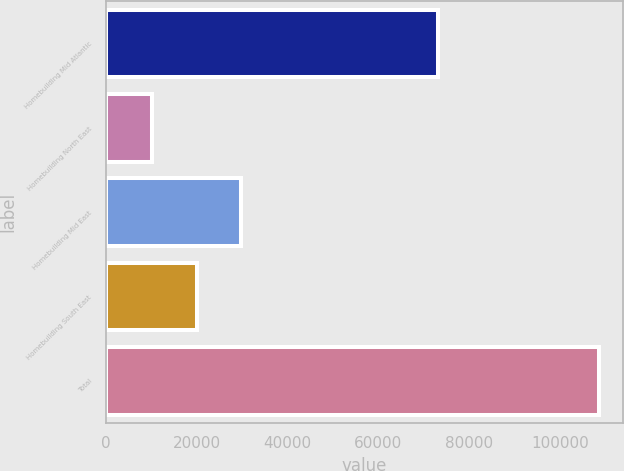Convert chart. <chart><loc_0><loc_0><loc_500><loc_500><bar_chart><fcel>Homebuilding Mid Atlantic<fcel>Homebuilding North East<fcel>Homebuilding Mid East<fcel>Homebuilding South East<fcel>Total<nl><fcel>73042<fcel>10081<fcel>29766.6<fcel>19923.8<fcel>108509<nl></chart> 